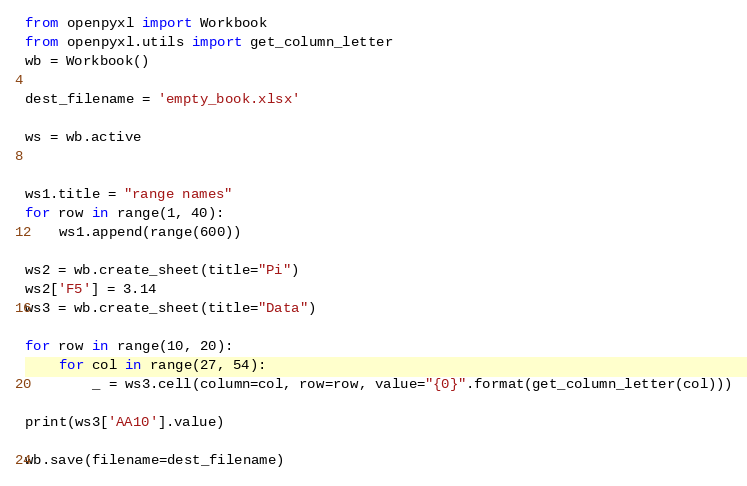<code> <loc_0><loc_0><loc_500><loc_500><_Python_>from openpyxl import Workbook
from openpyxl.utils import get_column_letter
wb = Workbook()

dest_filename = 'empty_book.xlsx'

ws = wb.active


ws1.title = "range names"
for row in range(1, 40):
    ws1.append(range(600))

ws2 = wb.create_sheet(title="Pi")
ws2['F5'] = 3.14
ws3 = wb.create_sheet(title="Data")

for row in range(10, 20):
    for col in range(27, 54):
        _ = ws3.cell(column=col, row=row, value="{0}".format(get_column_letter(col)))

print(ws3['AA10'].value)

wb.save(filename=dest_filename)</code> 